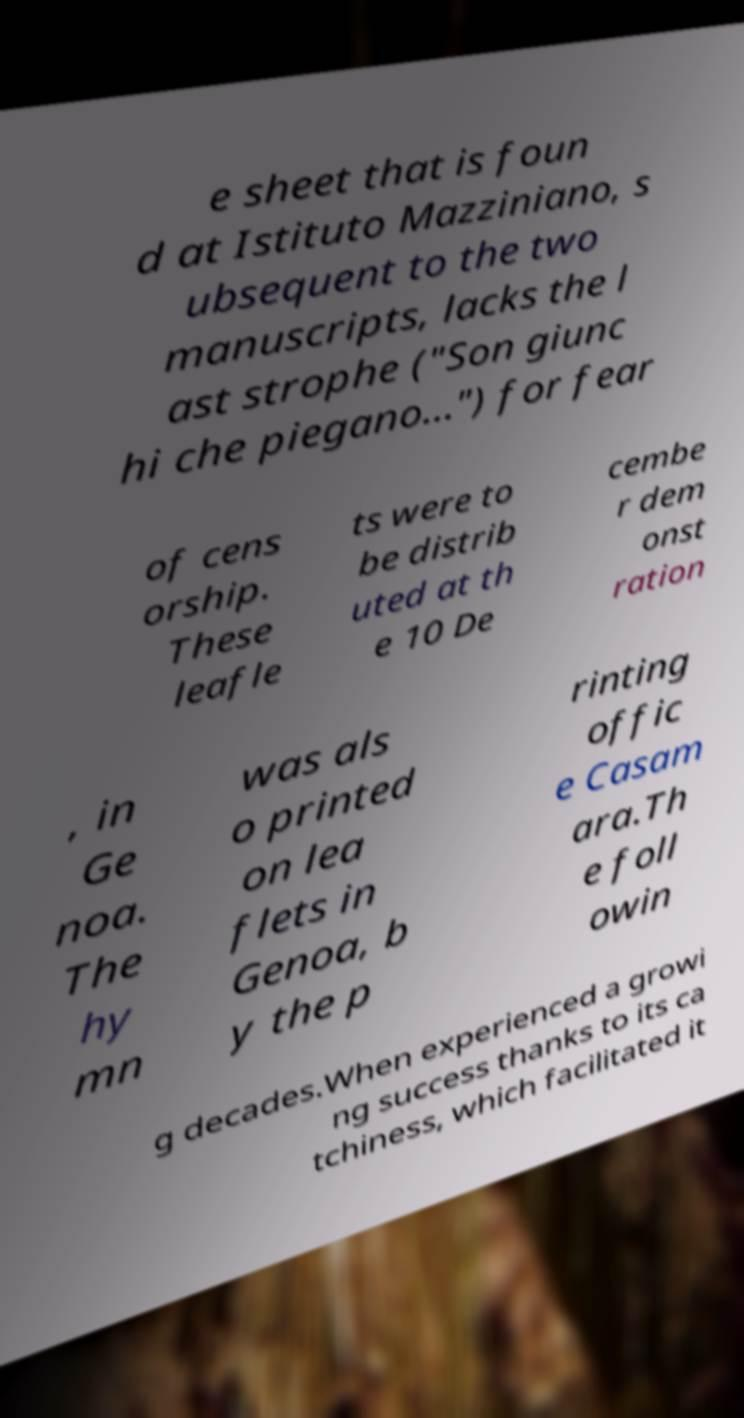What messages or text are displayed in this image? I need them in a readable, typed format. e sheet that is foun d at Istituto Mazziniano, s ubsequent to the two manuscripts, lacks the l ast strophe ("Son giunc hi che piegano...") for fear of cens orship. These leafle ts were to be distrib uted at th e 10 De cembe r dem onst ration , in Ge noa. The hy mn was als o printed on lea flets in Genoa, b y the p rinting offic e Casam ara.Th e foll owin g decades.When experienced a growi ng success thanks to its ca tchiness, which facilitated it 